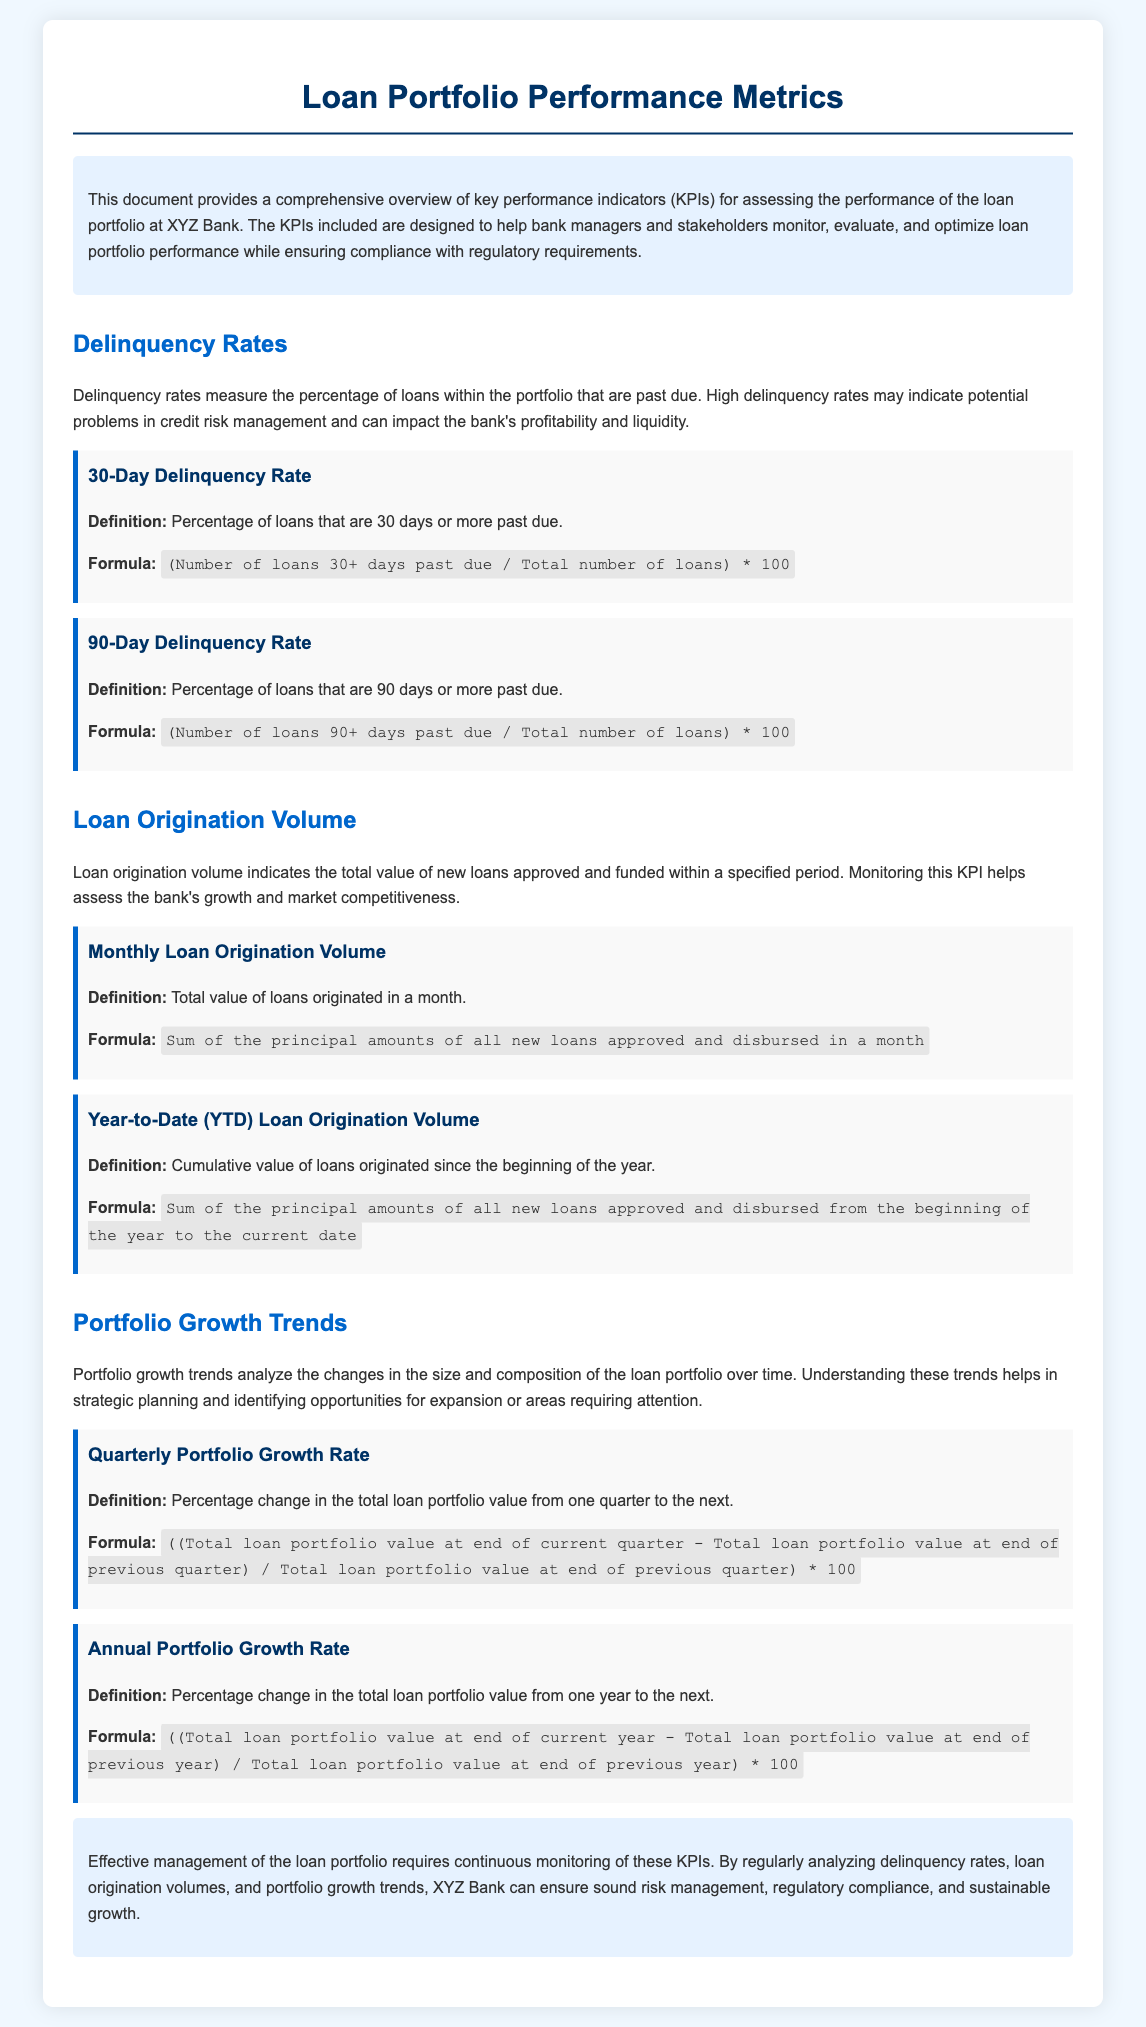what is the title of the document? The title of the document is prominently displayed at the top of the page and indicates the focus on loan portfolio performance metrics.
Answer: Loan Portfolio Performance Metrics what does the 30-Day Delinquency Rate measure? It measures the percentage of loans that are 30 days or more past due, indicating potential credit risk issues.
Answer: Percentage of loans that are 30 days or more past due what is the formula for calculating the 90-Day Delinquency Rate? The formula is provided in the document to quantify the portion of loans that are significantly overdue, reflecting the institution's credit risk.
Answer: (Number of loans 90+ days past due / Total number of loans) * 100 how often should the Quarterly Portfolio Growth Rate be assessed? This metric assesses the portfolio's quarterly performance, indicating the need for critical periodic evaluations to inform risk management and planning.
Answer: Quarterly what is the definition of Year-to-Date Loan Origination Volume? The document defines this metric as the cumulative value of loans originated since the beginning of the year, which is essential for evaluating growth.
Answer: Cumulative value of loans originated since the beginning of the year what can high delinquency rates indicate? High delinquency rates are a warning sign that could highlight significant issues in the bank’s credit risk management and can negatively affect profitability and liquidity.
Answer: Potential problems in credit risk management what does the conclusion of the document emphasize? The conclusion reiterates the importance of continuous monitoring of KPIs for effective loan portfolio management, underscoring the goal of sound risk management and compliance.
Answer: Effective management of the loan portfolio requires continuous monitoring of these KPIs what is the color of the main headings in the document? The main headings utilize a specific color scheme that distinguishes various sections for clarity and easier navigation through the content.
Answer: Dark blue 